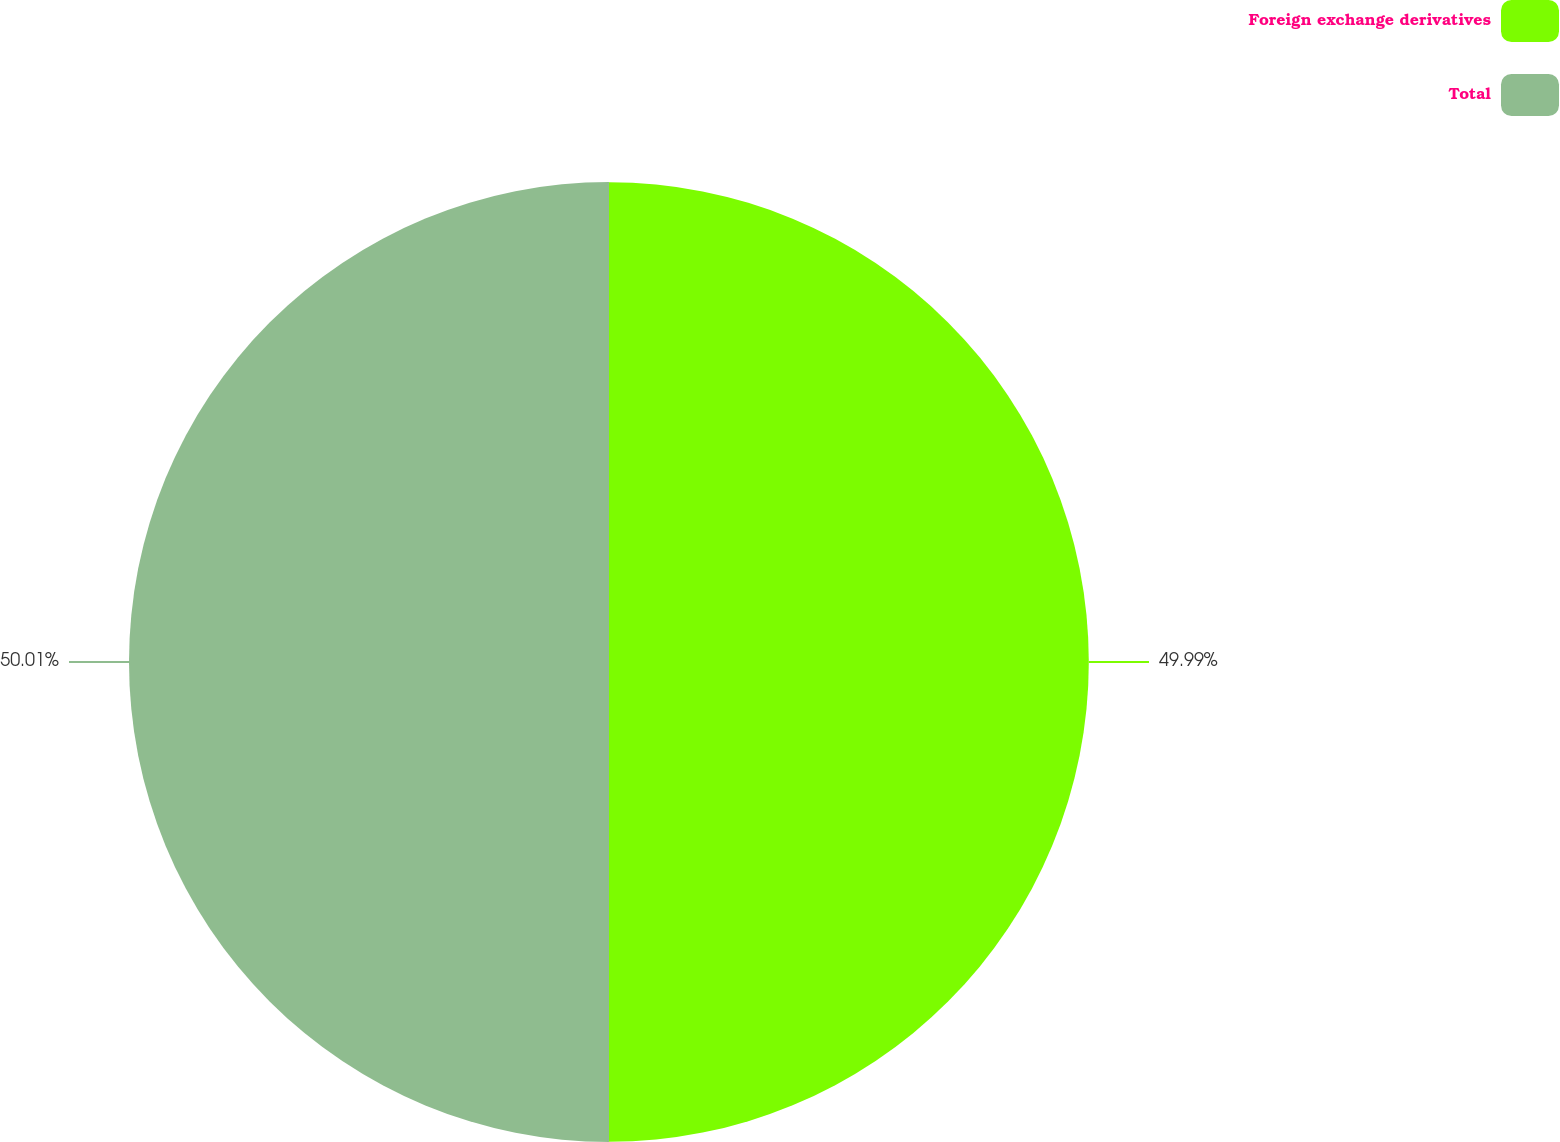<chart> <loc_0><loc_0><loc_500><loc_500><pie_chart><fcel>Foreign exchange derivatives<fcel>Total<nl><fcel>49.99%<fcel>50.01%<nl></chart> 